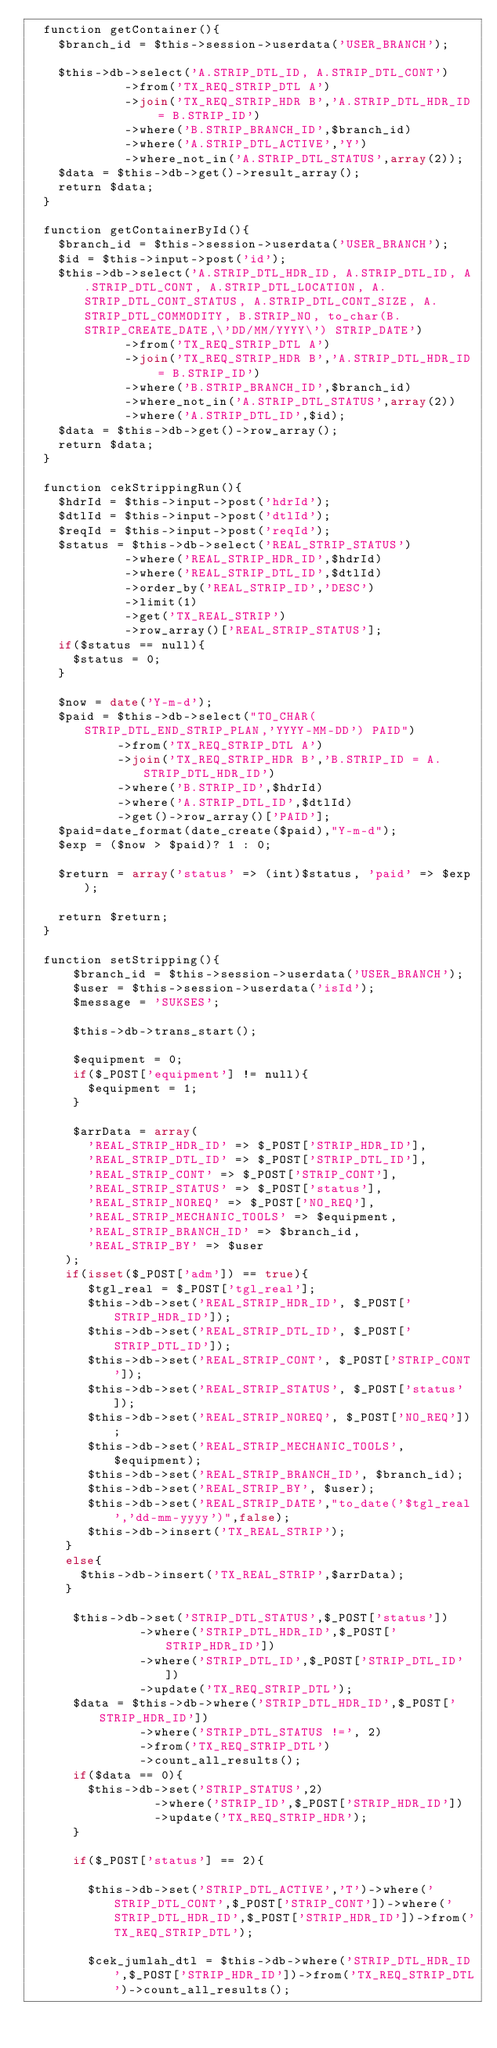Convert code to text. <code><loc_0><loc_0><loc_500><loc_500><_PHP_>  function getContainer(){
    $branch_id = $this->session->userdata('USER_BRANCH');

    $this->db->select('A.STRIP_DTL_ID, A.STRIP_DTL_CONT')
             ->from('TX_REQ_STRIP_DTL A')
             ->join('TX_REQ_STRIP_HDR B','A.STRIP_DTL_HDR_ID = B.STRIP_ID')
             ->where('B.STRIP_BRANCH_ID',$branch_id)
						 ->where('A.STRIP_DTL_ACTIVE','Y')
             ->where_not_in('A.STRIP_DTL_STATUS',array(2));
    $data = $this->db->get()->result_array();
    return $data;
  }

  function getContainerById(){
    $branch_id = $this->session->userdata('USER_BRANCH');
    $id = $this->input->post('id');
    $this->db->select('A.STRIP_DTL_HDR_ID, A.STRIP_DTL_ID, A.STRIP_DTL_CONT, A.STRIP_DTL_LOCATION, A.STRIP_DTL_CONT_STATUS, A.STRIP_DTL_CONT_SIZE, A.STRIP_DTL_COMMODITY, B.STRIP_NO, to_char(B.STRIP_CREATE_DATE,\'DD/MM/YYYY\') STRIP_DATE')
             ->from('TX_REQ_STRIP_DTL A')
             ->join('TX_REQ_STRIP_HDR B','A.STRIP_DTL_HDR_ID = B.STRIP_ID')
             ->where('B.STRIP_BRANCH_ID',$branch_id)
             ->where_not_in('A.STRIP_DTL_STATUS',array(2))
             ->where('A.STRIP_DTL_ID',$id);
    $data = $this->db->get()->row_array();
    return $data;
  }

	function cekStrippingRun(){
		$hdrId = $this->input->post('hdrId');
		$dtlId = $this->input->post('dtlId');
		$reqId = $this->input->post('reqId');
		$status = $this->db->select('REAL_STRIP_STATUS')
						 ->where('REAL_STRIP_HDR_ID',$hdrId)
						 ->where('REAL_STRIP_DTL_ID',$dtlId)
						 ->order_by('REAL_STRIP_ID','DESC')
						 ->limit(1)
						 ->get('TX_REAL_STRIP')
						 ->row_array()['REAL_STRIP_STATUS'];
		if($status == null){
			$status = 0;
		}

		$now = date('Y-m-d');
		$paid = $this->db->select("TO_CHAR(STRIP_DTL_END_STRIP_PLAN,'YYYY-MM-DD') PAID")
						->from('TX_REQ_STRIP_DTL A')
						->join('TX_REQ_STRIP_HDR B','B.STRIP_ID = A.STRIP_DTL_HDR_ID')
						->where('B.STRIP_ID',$hdrId)
						->where('A.STRIP_DTL_ID',$dtlId)
						->get()->row_array()['PAID'];
		$paid=date_format(date_create($paid),"Y-m-d");
		$exp = ($now > $paid)? 1 : 0;

		$return = array('status' => (int)$status, 'paid' => $exp);

		return $return;
	}

	function setStripping(){
			$branch_id = $this->session->userdata('USER_BRANCH');
			$user = $this->session->userdata('isId');
			$message = 'SUKSES';

			$this->db->trans_start();

			$equipment = 0;
			if($_POST['equipment'] != null){
				$equipment = 1;
			}

			$arrData = array(
				'REAL_STRIP_HDR_ID' => $_POST['STRIP_HDR_ID'],
				'REAL_STRIP_DTL_ID' => $_POST['STRIP_DTL_ID'],
				'REAL_STRIP_CONT' => $_POST['STRIP_CONT'],
				'REAL_STRIP_STATUS' => $_POST['status'],
				'REAL_STRIP_NOREQ' => $_POST['NO_REQ'],
				'REAL_STRIP_MECHANIC_TOOLS' => $equipment,
				'REAL_STRIP_BRANCH_ID' => $branch_id,
				'REAL_STRIP_BY' => $user
		 );
		 if(isset($_POST['adm']) == true){
				$tgl_real = $_POST['tgl_real'];
				$this->db->set('REAL_STRIP_HDR_ID', $_POST['STRIP_HDR_ID']);
				$this->db->set('REAL_STRIP_DTL_ID', $_POST['STRIP_DTL_ID']);
				$this->db->set('REAL_STRIP_CONT', $_POST['STRIP_CONT']);
				$this->db->set('REAL_STRIP_STATUS', $_POST['status']);
				$this->db->set('REAL_STRIP_NOREQ', $_POST['NO_REQ']);
				$this->db->set('REAL_STRIP_MECHANIC_TOOLS', $equipment);
				$this->db->set('REAL_STRIP_BRANCH_ID', $branch_id);
				$this->db->set('REAL_STRIP_BY', $user);
				$this->db->set('REAL_STRIP_DATE',"to_date('$tgl_real','dd-mm-yyyy')",false);
				$this->db->insert('TX_REAL_STRIP');
		 }
		 else{
			 $this->db->insert('TX_REAL_STRIP',$arrData);
		 }

			$this->db->set('STRIP_DTL_STATUS',$_POST['status'])
							 ->where('STRIP_DTL_HDR_ID',$_POST['STRIP_HDR_ID'])
							 ->where('STRIP_DTL_ID',$_POST['STRIP_DTL_ID'])
							 ->update('TX_REQ_STRIP_DTL');
			$data = $this->db->where('STRIP_DTL_HDR_ID',$_POST['STRIP_HDR_ID'])
					 		 ->where('STRIP_DTL_STATUS !=', 2)
							 ->from('TX_REQ_STRIP_DTL')
							 ->count_all_results();
			if($data == 0){
				$this->db->set('STRIP_STATUS',2)
								 ->where('STRIP_ID',$_POST['STRIP_HDR_ID'])
								 ->update('TX_REQ_STRIP_HDR');
			}

			if($_POST['status'] == 2){

				$this->db->set('STRIP_DTL_ACTIVE','T')->where('STRIP_DTL_CONT',$_POST['STRIP_CONT'])->where('STRIP_DTL_HDR_ID',$_POST['STRIP_HDR_ID'])->from('TX_REQ_STRIP_DTL');

				$cek_jumlah_dtl = $this->db->where('STRIP_DTL_HDR_ID',$_POST['STRIP_HDR_ID'])->from('TX_REQ_STRIP_DTL')->count_all_results();</code> 